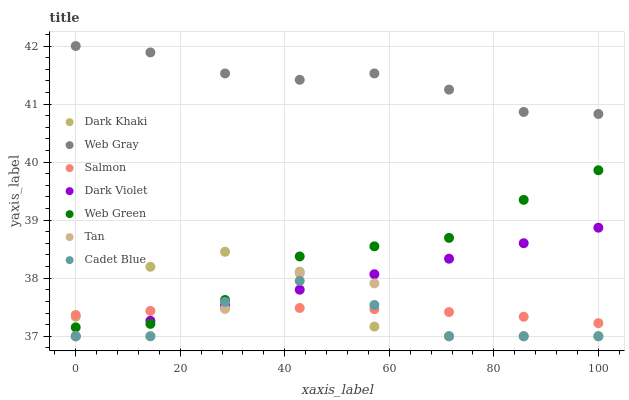Does Cadet Blue have the minimum area under the curve?
Answer yes or no. Yes. Does Web Gray have the maximum area under the curve?
Answer yes or no. Yes. Does Salmon have the minimum area under the curve?
Answer yes or no. No. Does Salmon have the maximum area under the curve?
Answer yes or no. No. Is Dark Violet the smoothest?
Answer yes or no. Yes. Is Tan the roughest?
Answer yes or no. Yes. Is Salmon the smoothest?
Answer yes or no. No. Is Salmon the roughest?
Answer yes or no. No. Does Dark Khaki have the lowest value?
Answer yes or no. Yes. Does Salmon have the lowest value?
Answer yes or no. No. Does Web Gray have the highest value?
Answer yes or no. Yes. Does Web Green have the highest value?
Answer yes or no. No. Is Cadet Blue less than Web Gray?
Answer yes or no. Yes. Is Web Gray greater than Web Green?
Answer yes or no. Yes. Does Web Green intersect Salmon?
Answer yes or no. Yes. Is Web Green less than Salmon?
Answer yes or no. No. Is Web Green greater than Salmon?
Answer yes or no. No. Does Cadet Blue intersect Web Gray?
Answer yes or no. No. 